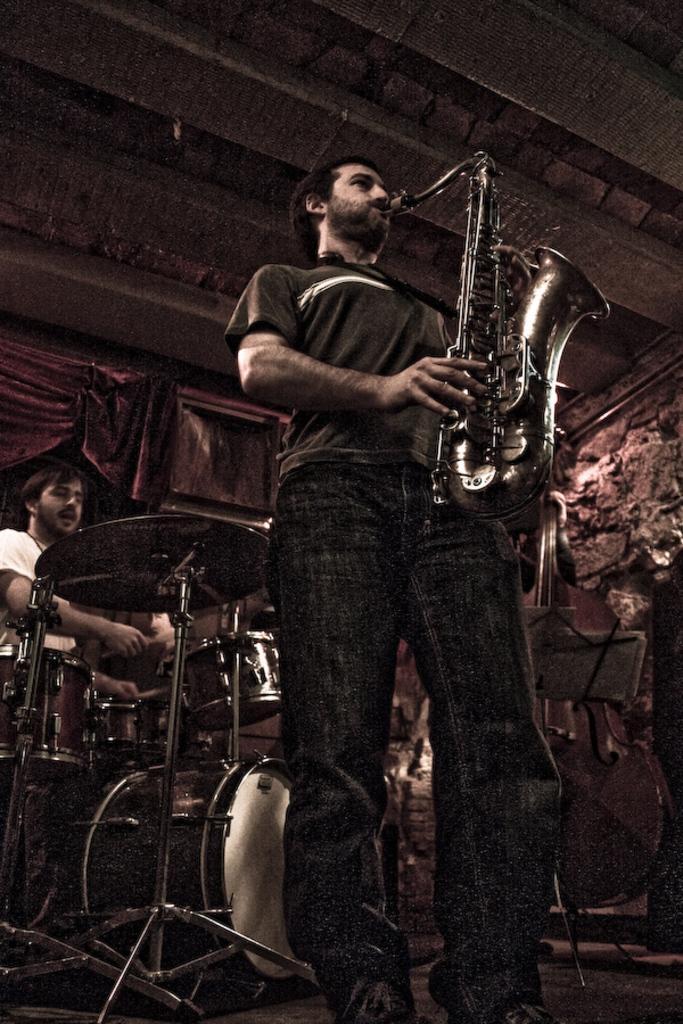Describe this image in one or two sentences. A man with t-shirt and pant is standing. He is playing a saxophone. Behind him there is another man with white t-shirt. He is playing drums. At the back of them there is a curtain. 